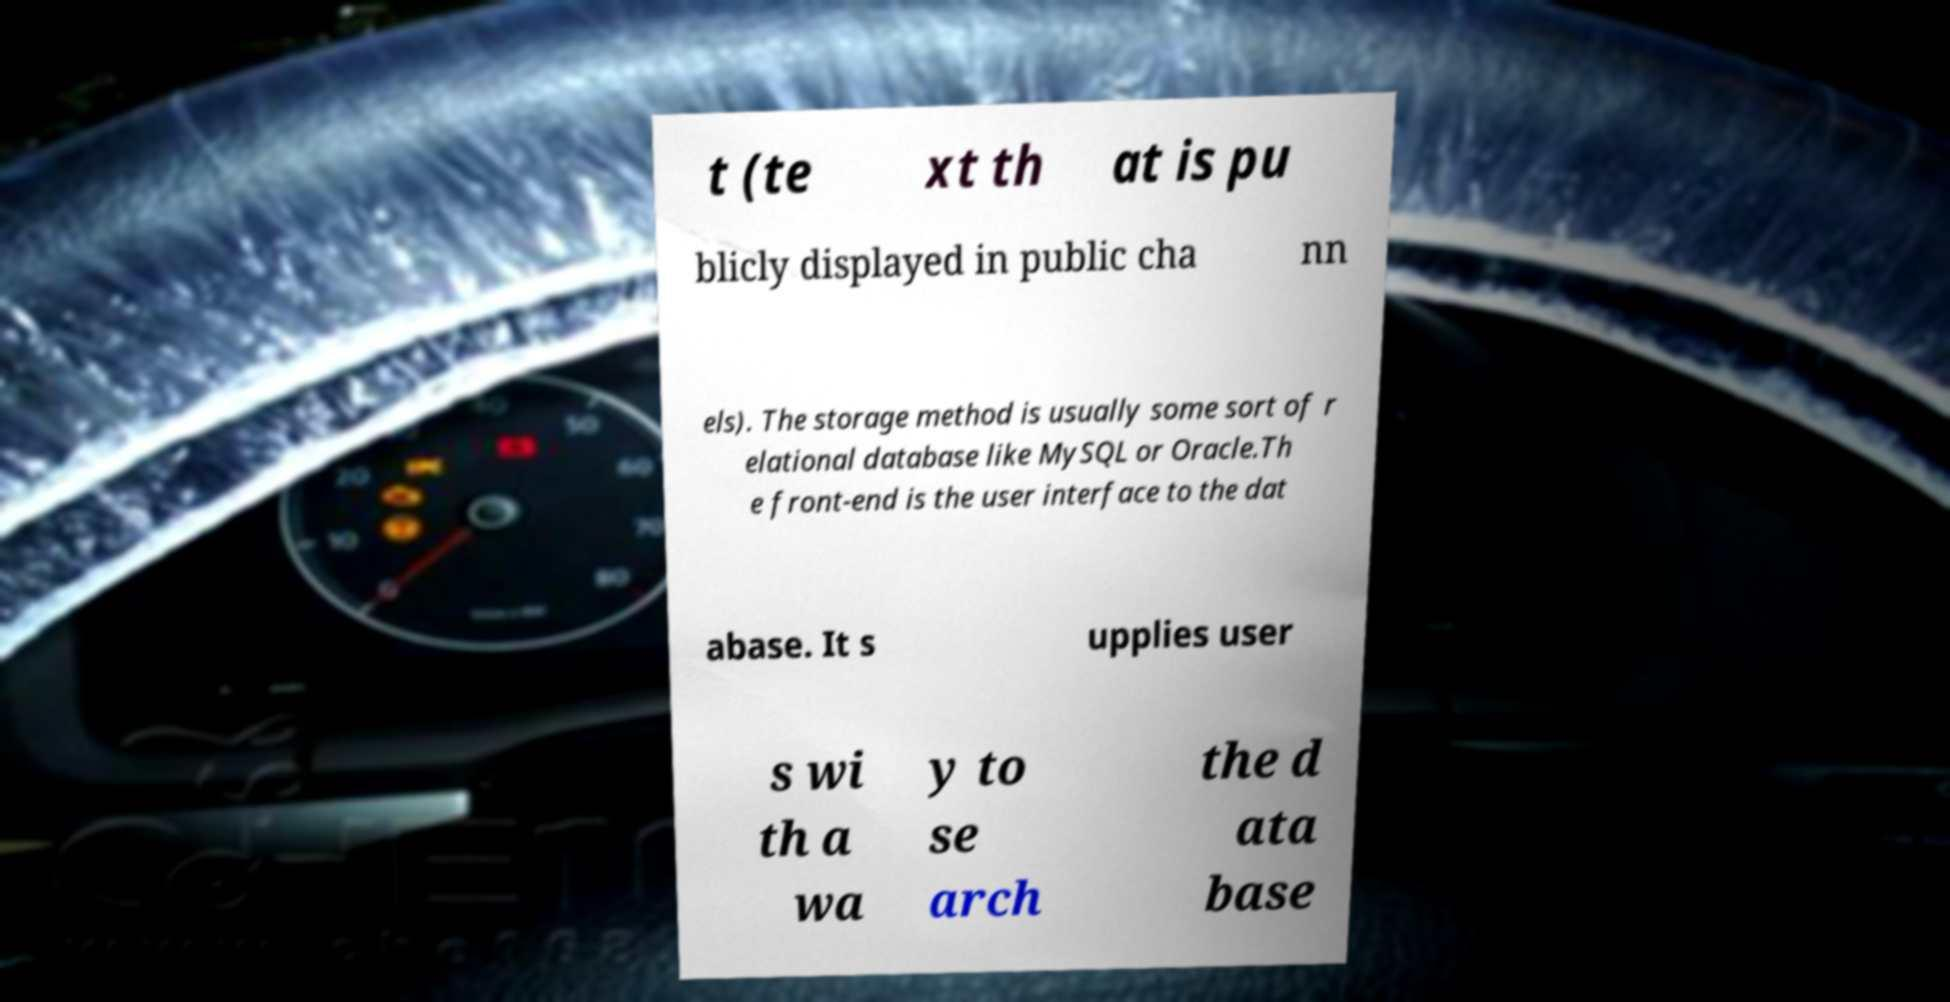There's text embedded in this image that I need extracted. Can you transcribe it verbatim? t (te xt th at is pu blicly displayed in public cha nn els). The storage method is usually some sort of r elational database like MySQL or Oracle.Th e front-end is the user interface to the dat abase. It s upplies user s wi th a wa y to se arch the d ata base 